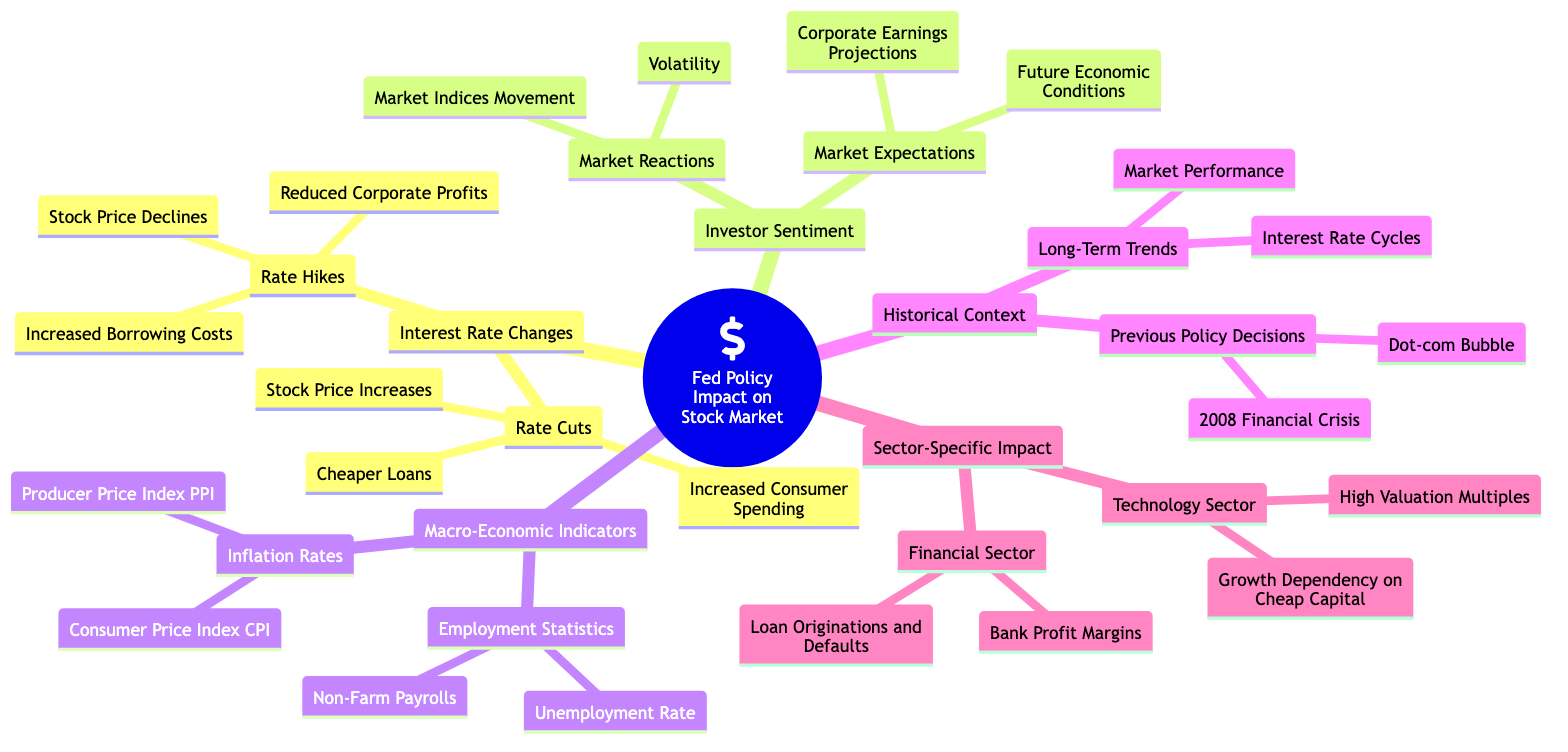What are the effects of rate hikes on corporate profits? The diagram states that rate hikes result in reduced corporate profits, drawing a direct relationship between interest rate changes and corporate financial performance.
Answer: Reduced Corporate Profits How many indicators are listed under Macro-Economic Indicators? There are two subcategories under Macro-Economic Indicators: Inflation Rates and Employment Statistics; each of these contains two specific indicators, totaling four indicators.
Answer: Four Which sector is listed as having a growth dependency on cheap capital? The Technology Sector is specifically mentioned in the diagram as having a growth dependency on cheap capital, highlighting its reliance on favorable interest rates to fuel growth.
Answer: Technology Sector What are the previous policy decisions noted in the Historical Context? The diagram lists the 2008 Financial Crisis and the Dot-com Bubble as previous policy decisions, signaling significant historical events related to interest rate policies.
Answer: 2008 Financial Crisis, Dot-com Bubble What sentiment is impacted by market expectations regarding economic conditions? Investor sentiment is impacted by market expectations concerning future economic conditions, indicating that investor perceptions can influence market stability and performance.
Answer: Future Economic Conditions What specific impact do rate cuts have on consumer behavior? The diagram indicates that rate cuts lead to increased consumer spending, showing a direct relationship whereby lower interest rates encourage consumers to spend more.
Answer: Increased Consumer Spending How do market reactions manifest according to the diagram? Market reactions are characterized by volatility and market indices movement, suggesting that changes in interest rate policies can create fluctuations in the stock market.
Answer: Volatility, Market Indices Movement Which economic statistics are included under Employment Statistics? The diagram includes the Unemployment Rate and Non-Farm Payrolls under Employment Statistics, highlighting important labor market measures that could influence Federal Reserve policies.
Answer: Unemployment Rate, Non-Farm Payrolls What does the Technology Sector's high valuation multiples imply? High valuation multiples for the Technology Sector suggest that companies are valued at higher ratios compared to their earnings, potentially due to growth expectations despite interest rate concerns.
Answer: High Valuation Multiples 